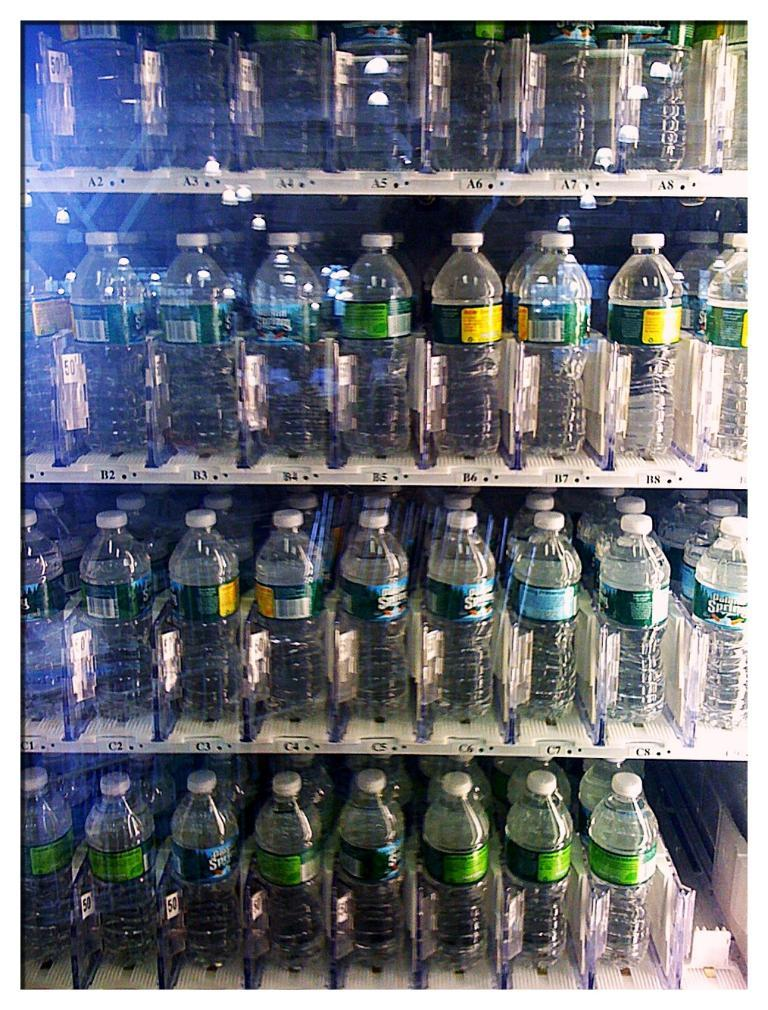What objects are on the racks in the image? There are bottles on the racks in the image. What statement can be made about the berries in the image? There are no berries present in the image, so no statement can be made about them. 